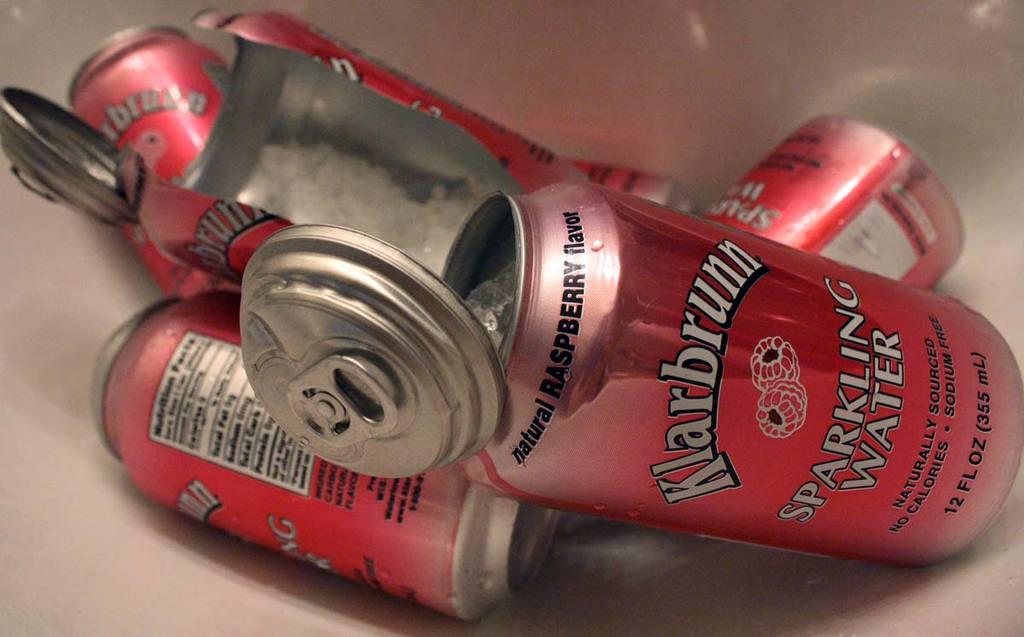What kind of water is this?
Provide a succinct answer. Sparkling. 